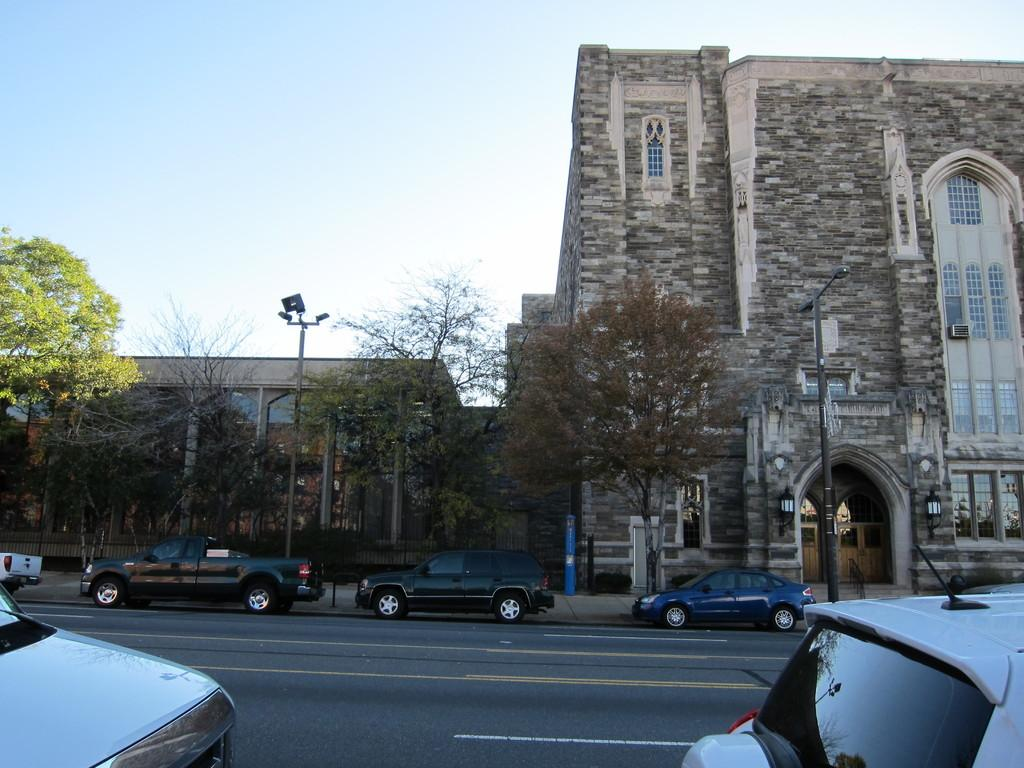Where was the image taken? The image is taken on the road. What can be seen on the road in the image? There are cars on the road in the image. What is located in the center of the image? There are poles and trees in the center of the image. What can be seen in the background of the image? There are buildings and the sky visible in the background of the image. What type of reaction can be seen on the table in the image? There is no table present in the image, and therefore no reaction can be observed on it. 